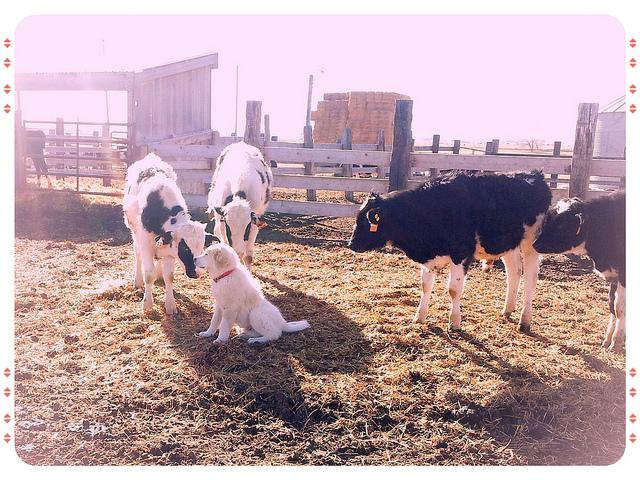What are the cows looking at? Please explain your reasoning. dog. The cows are looking at the dog. 